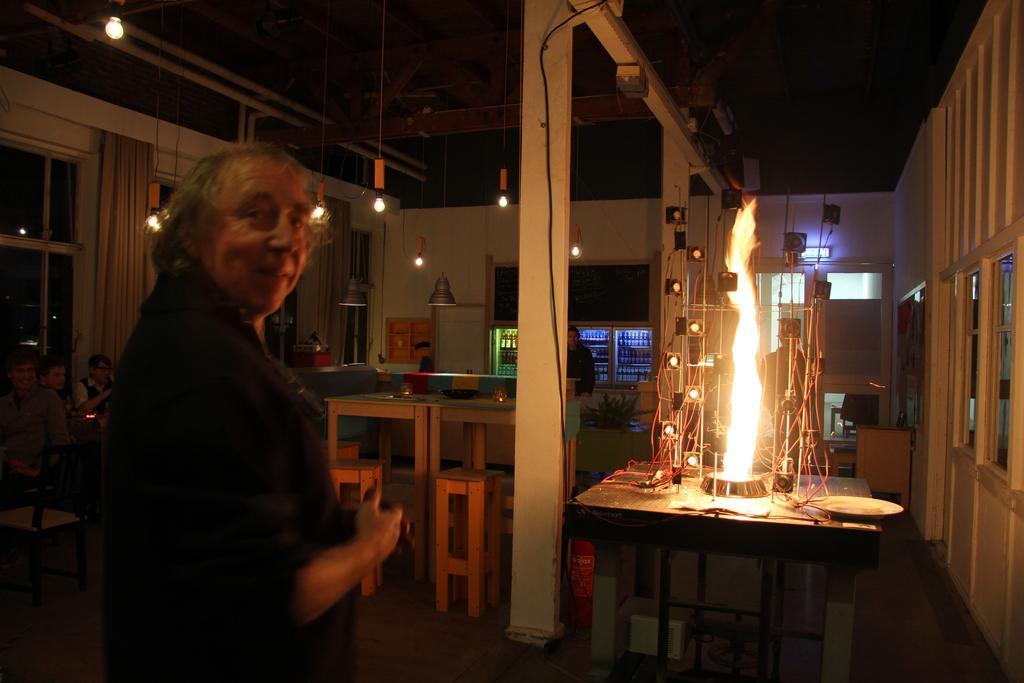In one or two sentences, can you explain what this image depicts? In this image I see a man over here who is smiling and I see the fire over here and I see few things on this table. In the background I see few more people, stools and more tables and I see the lights and I see the wall and the ceiling. 